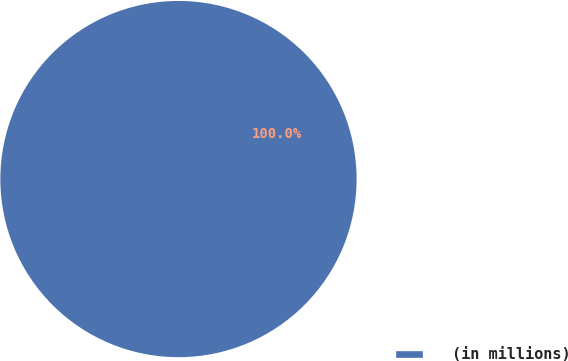<chart> <loc_0><loc_0><loc_500><loc_500><pie_chart><fcel>(in millions)<nl><fcel>100.0%<nl></chart> 